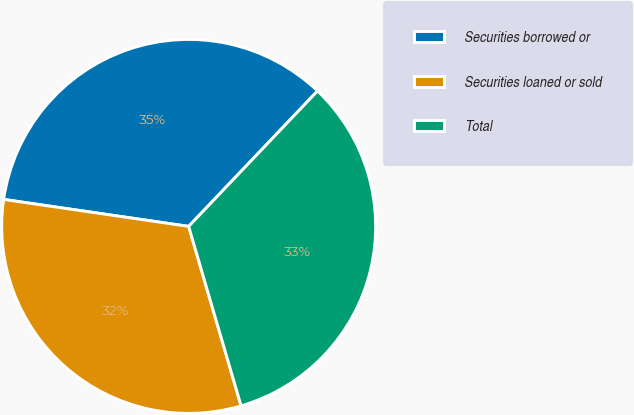Convert chart. <chart><loc_0><loc_0><loc_500><loc_500><pie_chart><fcel>Securities borrowed or<fcel>Securities loaned or sold<fcel>Total<nl><fcel>34.8%<fcel>31.83%<fcel>33.37%<nl></chart> 